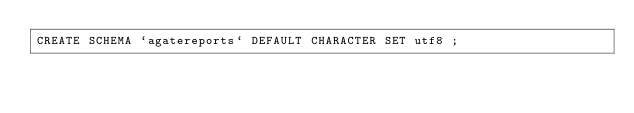Convert code to text. <code><loc_0><loc_0><loc_500><loc_500><_SQL_>CREATE SCHEMA `agatereports` DEFAULT CHARACTER SET utf8 ;

</code> 